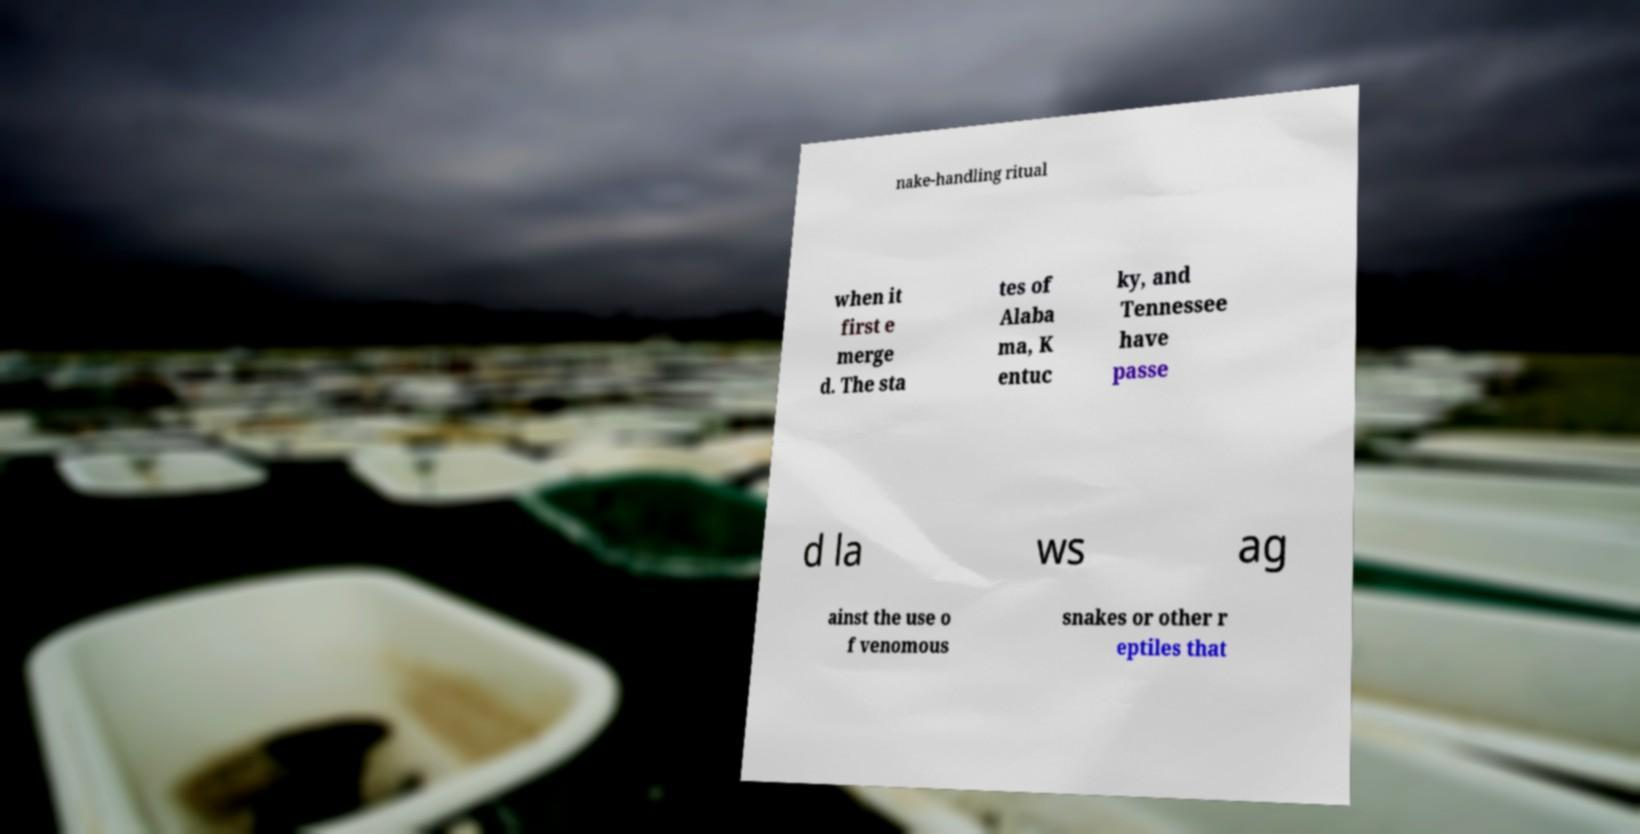For documentation purposes, I need the text within this image transcribed. Could you provide that? nake-handling ritual when it first e merge d. The sta tes of Alaba ma, K entuc ky, and Tennessee have passe d la ws ag ainst the use o f venomous snakes or other r eptiles that 